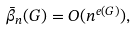Convert formula to latex. <formula><loc_0><loc_0><loc_500><loc_500>\bar { \beta } _ { n } ( G ) = O ( n ^ { e ( G ) } ) ,</formula> 